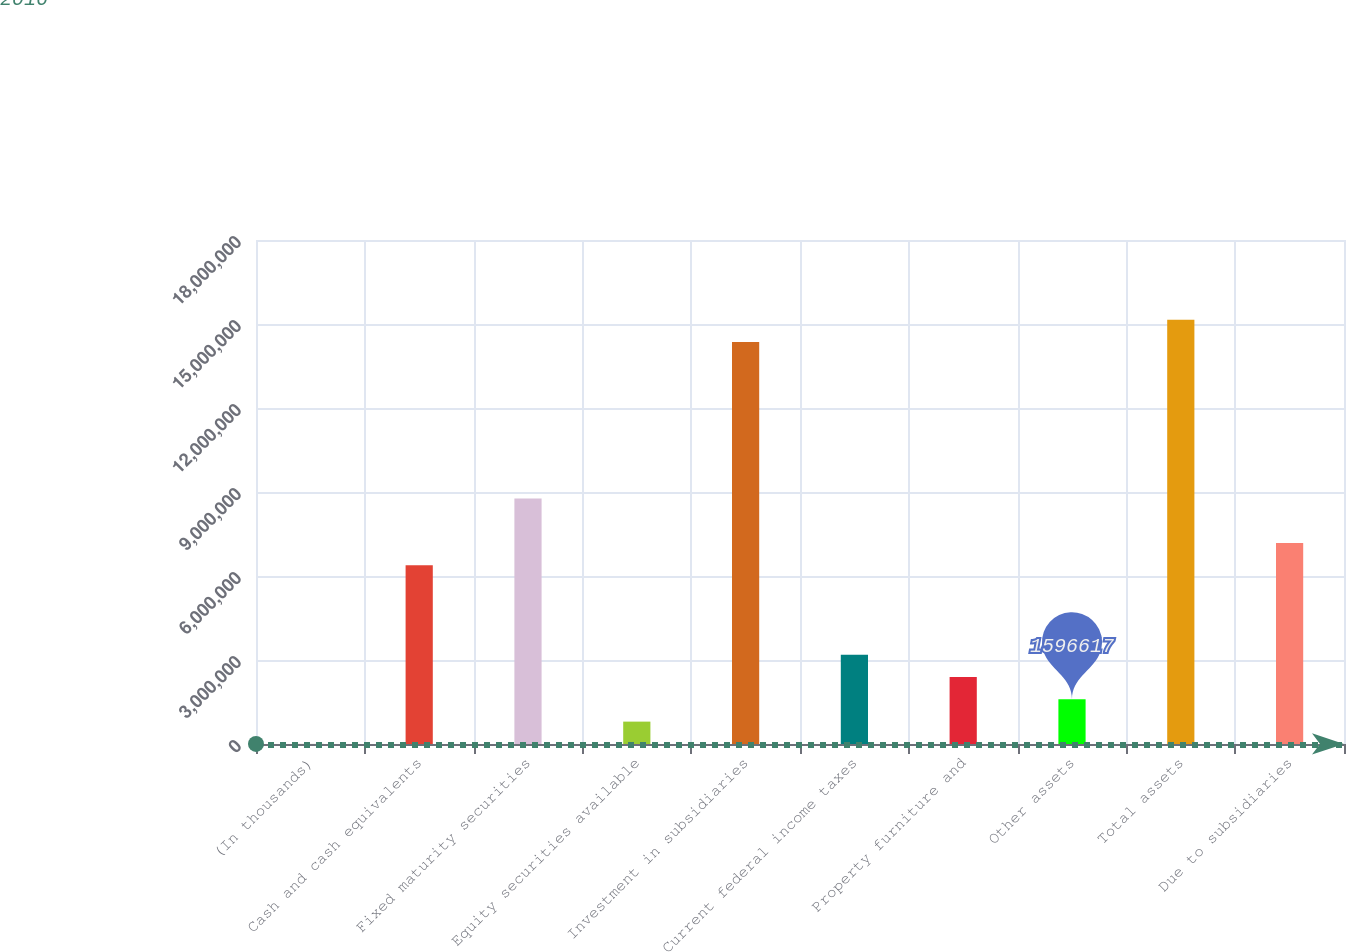Convert chart to OTSL. <chart><loc_0><loc_0><loc_500><loc_500><bar_chart><fcel>(In thousands)<fcel>Cash and cash equivalents<fcel>Fixed maturity securities<fcel>Equity securities available<fcel>Investment in subsidiaries<fcel>Current federal income taxes<fcel>Property furniture and<fcel>Other assets<fcel>Total assets<fcel>Due to subsidiaries<nl><fcel>2016<fcel>6.38042e+06<fcel>8.77232e+06<fcel>799316<fcel>1.43534e+07<fcel>3.19122e+06<fcel>2.39392e+06<fcel>1.59662e+06<fcel>1.51507e+07<fcel>7.17772e+06<nl></chart> 